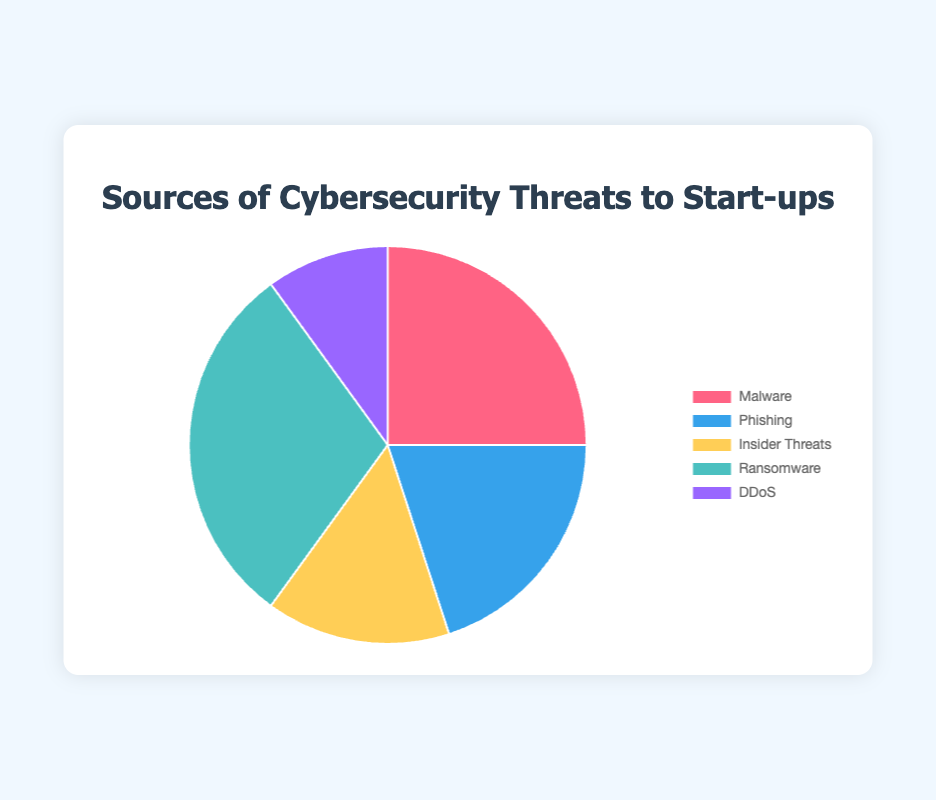What percentage of cybersecurity threats to start-ups is due to phishing? Look at the segment labeled "Phishing" in the pie chart. The corresponding legend indicates phishing contributes to 20% of the threats.
Answer: 20% Which source of cybersecurity threat has the smallest percentage? Compare all segments of the pie chart to find the one with the smallest percentage. DDoS is the smallest segment, contributing 10%.
Answer: DDoS Is the percentage of ransomware threats greater than the percentage of insider threats? Compare the segments for ransomware (30%) and insider threats (15%). Since 30% is greater than 15%, ransomware threats are indeed greater.
Answer: Yes What is the combined percentage of malware and phishing threats? Sum the percentages for the malware (25%) and phishing (20%) segments. 25% + 20% = 45%.
Answer: 45% Which threat type has the highest percentage, and what is it? Identify the largest segment by size. The legend shows ransomware as the largest segment, contributing 30%.
Answer: Ransomware, 30% How much greater is the percentage of malware threats compared to DDoS threats? Subtract the percentage of DDoS threats (10%) from the percentage of malware threats (25%). 25% - 10% = 15%.
Answer: 15% If you combine phishing and insider threats, does it exceed malware's percentage? Add percentages for phishing (20%) and insider threats (15%), giving 35%. Compare to malware's 25%. Since 35% > 25%, the combined percentage is greater.
Answer: Yes What is the sum of the percentages of the three smallest threat categories? Add the percentages of phishing (20%), insider threats (15%), and DDoS (10%). 20% + 15% + 10% = 45%.
Answer: 45% What color represents DDoS threats in the pie chart? Identify the segment labeled "DDoS" and match it with the corresponding color in the legend. DDoS is represented by a purple segment.
Answer: Purple If you were to group together all the non-ransomware threats, what percentage would they collectively contribute to? Sum the percentages of non-ransomware threats: malware (25%), phishing (20%), insider threats (15%), and DDoS (10%). 25% + 20% + 15% + 10% = 70%.
Answer: 70% 